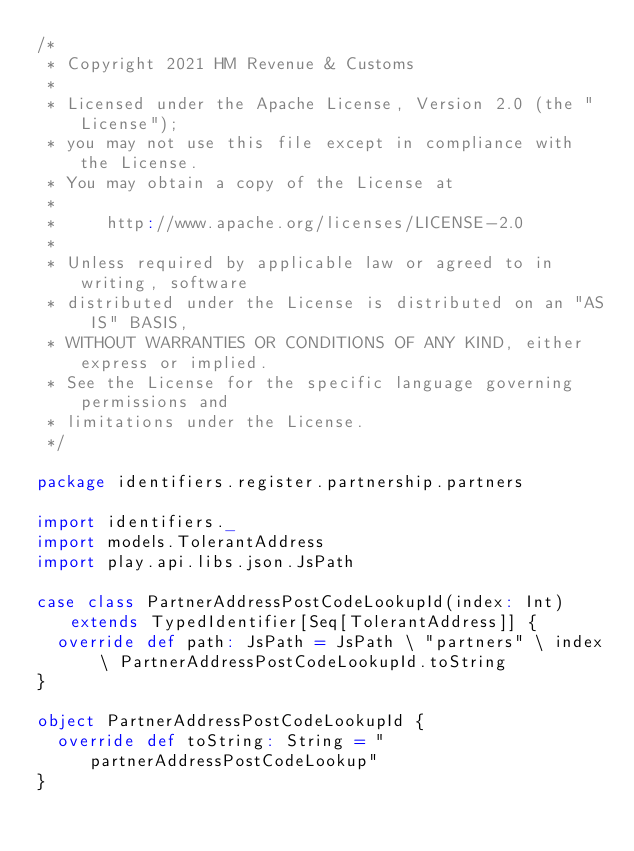<code> <loc_0><loc_0><loc_500><loc_500><_Scala_>/*
 * Copyright 2021 HM Revenue & Customs
 *
 * Licensed under the Apache License, Version 2.0 (the "License");
 * you may not use this file except in compliance with the License.
 * You may obtain a copy of the License at
 *
 *     http://www.apache.org/licenses/LICENSE-2.0
 *
 * Unless required by applicable law or agreed to in writing, software
 * distributed under the License is distributed on an "AS IS" BASIS,
 * WITHOUT WARRANTIES OR CONDITIONS OF ANY KIND, either express or implied.
 * See the License for the specific language governing permissions and
 * limitations under the License.
 */

package identifiers.register.partnership.partners

import identifiers._
import models.TolerantAddress
import play.api.libs.json.JsPath

case class PartnerAddressPostCodeLookupId(index: Int) extends TypedIdentifier[Seq[TolerantAddress]] {
  override def path: JsPath = JsPath \ "partners" \ index \ PartnerAddressPostCodeLookupId.toString
}

object PartnerAddressPostCodeLookupId {
  override def toString: String = "partnerAddressPostCodeLookup"
}


</code> 